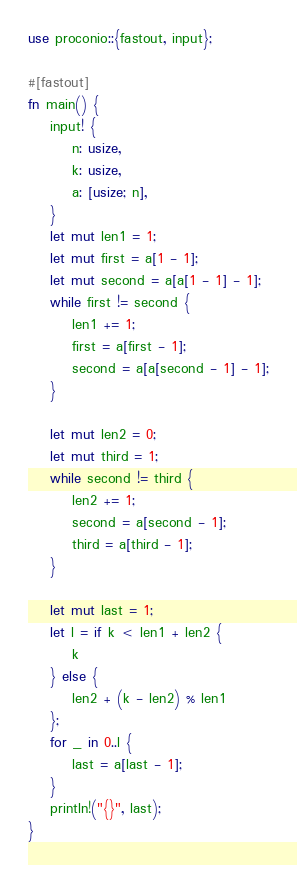Convert code to text. <code><loc_0><loc_0><loc_500><loc_500><_Rust_>use proconio::{fastout, input};

#[fastout]
fn main() {
    input! {
        n: usize,
        k: usize,
        a: [usize; n],
    }
    let mut len1 = 1;
    let mut first = a[1 - 1];
    let mut second = a[a[1 - 1] - 1];
    while first != second {
        len1 += 1;
        first = a[first - 1];
        second = a[a[second - 1] - 1];
    }

    let mut len2 = 0;
    let mut third = 1;
    while second != third {
        len2 += 1;
        second = a[second - 1];
        third = a[third - 1];
    }

    let mut last = 1;
    let l = if k < len1 + len2 {
        k
    } else {
        len2 + (k - len2) % len1
    };
    for _ in 0..l {
        last = a[last - 1];
    }
    println!("{}", last);
}
</code> 